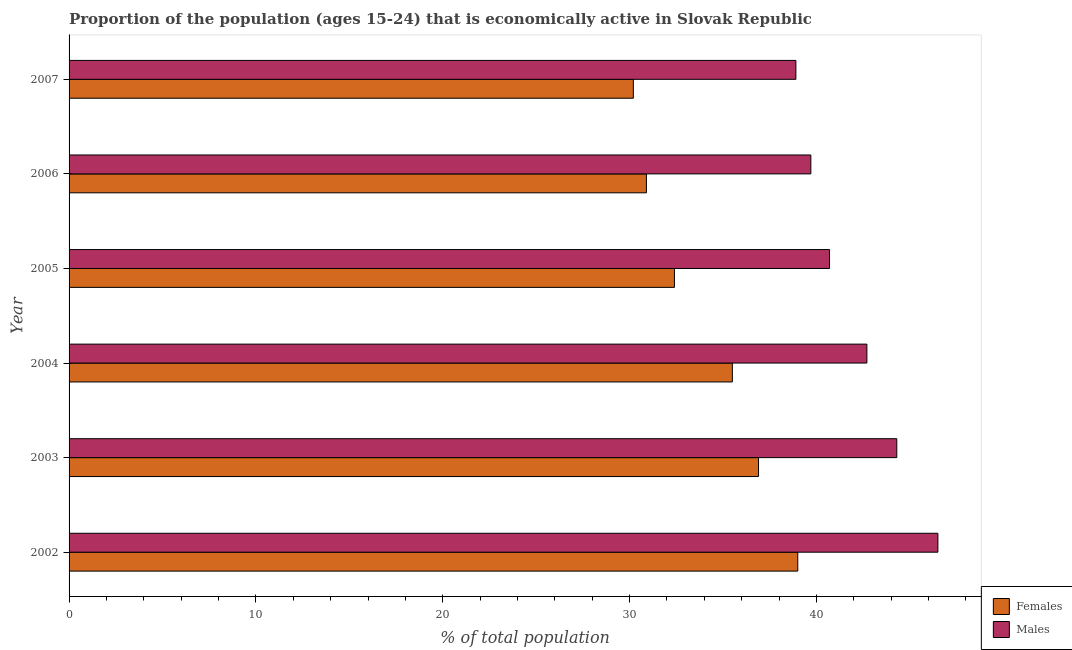How many different coloured bars are there?
Your response must be concise. 2. Are the number of bars per tick equal to the number of legend labels?
Offer a very short reply. Yes. Are the number of bars on each tick of the Y-axis equal?
Offer a very short reply. Yes. How many bars are there on the 3rd tick from the top?
Your response must be concise. 2. How many bars are there on the 1st tick from the bottom?
Offer a very short reply. 2. What is the percentage of economically active male population in 2004?
Make the answer very short. 42.7. Across all years, what is the maximum percentage of economically active female population?
Make the answer very short. 39. Across all years, what is the minimum percentage of economically active male population?
Your answer should be very brief. 38.9. In which year was the percentage of economically active female population minimum?
Your answer should be compact. 2007. What is the total percentage of economically active female population in the graph?
Provide a succinct answer. 204.9. What is the difference between the percentage of economically active male population in 2003 and that in 2006?
Your answer should be very brief. 4.6. What is the difference between the percentage of economically active male population in 2006 and the percentage of economically active female population in 2007?
Offer a terse response. 9.5. What is the average percentage of economically active female population per year?
Your answer should be compact. 34.15. In the year 2007, what is the difference between the percentage of economically active female population and percentage of economically active male population?
Your response must be concise. -8.7. What is the ratio of the percentage of economically active female population in 2003 to that in 2007?
Offer a very short reply. 1.22. Is the percentage of economically active male population in 2002 less than that in 2006?
Provide a succinct answer. No. What is the difference between the highest and the second highest percentage of economically active male population?
Your answer should be compact. 2.2. What is the difference between the highest and the lowest percentage of economically active female population?
Your answer should be very brief. 8.8. In how many years, is the percentage of economically active female population greater than the average percentage of economically active female population taken over all years?
Keep it short and to the point. 3. Is the sum of the percentage of economically active male population in 2002 and 2006 greater than the maximum percentage of economically active female population across all years?
Offer a terse response. Yes. What does the 2nd bar from the top in 2007 represents?
Your answer should be compact. Females. What does the 2nd bar from the bottom in 2007 represents?
Ensure brevity in your answer.  Males. How many bars are there?
Keep it short and to the point. 12. Are all the bars in the graph horizontal?
Provide a short and direct response. Yes. How many years are there in the graph?
Keep it short and to the point. 6. What is the difference between two consecutive major ticks on the X-axis?
Provide a succinct answer. 10. Are the values on the major ticks of X-axis written in scientific E-notation?
Your answer should be very brief. No. How many legend labels are there?
Offer a very short reply. 2. What is the title of the graph?
Your response must be concise. Proportion of the population (ages 15-24) that is economically active in Slovak Republic. Does "Underweight" appear as one of the legend labels in the graph?
Provide a short and direct response. No. What is the label or title of the X-axis?
Ensure brevity in your answer.  % of total population. What is the label or title of the Y-axis?
Make the answer very short. Year. What is the % of total population of Females in 2002?
Provide a short and direct response. 39. What is the % of total population of Males in 2002?
Give a very brief answer. 46.5. What is the % of total population of Females in 2003?
Offer a very short reply. 36.9. What is the % of total population in Males in 2003?
Ensure brevity in your answer.  44.3. What is the % of total population of Females in 2004?
Ensure brevity in your answer.  35.5. What is the % of total population of Males in 2004?
Keep it short and to the point. 42.7. What is the % of total population in Females in 2005?
Your answer should be very brief. 32.4. What is the % of total population in Males in 2005?
Ensure brevity in your answer.  40.7. What is the % of total population in Females in 2006?
Keep it short and to the point. 30.9. What is the % of total population in Males in 2006?
Provide a short and direct response. 39.7. What is the % of total population of Females in 2007?
Keep it short and to the point. 30.2. What is the % of total population in Males in 2007?
Give a very brief answer. 38.9. Across all years, what is the maximum % of total population of Males?
Your response must be concise. 46.5. Across all years, what is the minimum % of total population of Females?
Keep it short and to the point. 30.2. Across all years, what is the minimum % of total population in Males?
Provide a succinct answer. 38.9. What is the total % of total population in Females in the graph?
Your answer should be very brief. 204.9. What is the total % of total population of Males in the graph?
Your response must be concise. 252.8. What is the difference between the % of total population in Males in 2002 and that in 2004?
Provide a succinct answer. 3.8. What is the difference between the % of total population of Males in 2002 and that in 2005?
Your answer should be very brief. 5.8. What is the difference between the % of total population in Females in 2002 and that in 2006?
Your answer should be very brief. 8.1. What is the difference between the % of total population of Males in 2002 and that in 2006?
Offer a very short reply. 6.8. What is the difference between the % of total population of Females in 2002 and that in 2007?
Give a very brief answer. 8.8. What is the difference between the % of total population of Males in 2003 and that in 2004?
Give a very brief answer. 1.6. What is the difference between the % of total population of Females in 2003 and that in 2005?
Offer a terse response. 4.5. What is the difference between the % of total population in Males in 2003 and that in 2005?
Your response must be concise. 3.6. What is the difference between the % of total population in Females in 2003 and that in 2006?
Your answer should be compact. 6. What is the difference between the % of total population of Males in 2003 and that in 2006?
Provide a short and direct response. 4.6. What is the difference between the % of total population of Females in 2003 and that in 2007?
Ensure brevity in your answer.  6.7. What is the difference between the % of total population of Males in 2003 and that in 2007?
Offer a terse response. 5.4. What is the difference between the % of total population of Females in 2004 and that in 2005?
Make the answer very short. 3.1. What is the difference between the % of total population of Males in 2004 and that in 2006?
Offer a terse response. 3. What is the difference between the % of total population of Females in 2004 and that in 2007?
Give a very brief answer. 5.3. What is the difference between the % of total population of Males in 2005 and that in 2006?
Offer a terse response. 1. What is the difference between the % of total population in Males in 2005 and that in 2007?
Offer a terse response. 1.8. What is the difference between the % of total population in Females in 2006 and that in 2007?
Your answer should be compact. 0.7. What is the difference between the % of total population in Males in 2006 and that in 2007?
Offer a terse response. 0.8. What is the difference between the % of total population of Females in 2002 and the % of total population of Males in 2004?
Offer a very short reply. -3.7. What is the difference between the % of total population in Females in 2002 and the % of total population in Males in 2005?
Your response must be concise. -1.7. What is the difference between the % of total population of Females in 2002 and the % of total population of Males in 2006?
Offer a very short reply. -0.7. What is the difference between the % of total population in Females in 2003 and the % of total population in Males in 2005?
Keep it short and to the point. -3.8. What is the difference between the % of total population in Females in 2004 and the % of total population in Males in 2005?
Ensure brevity in your answer.  -5.2. What is the difference between the % of total population of Females in 2004 and the % of total population of Males in 2006?
Your response must be concise. -4.2. What is the difference between the % of total population of Females in 2005 and the % of total population of Males in 2006?
Offer a terse response. -7.3. What is the difference between the % of total population of Females in 2005 and the % of total population of Males in 2007?
Make the answer very short. -6.5. What is the difference between the % of total population in Females in 2006 and the % of total population in Males in 2007?
Offer a very short reply. -8. What is the average % of total population in Females per year?
Give a very brief answer. 34.15. What is the average % of total population in Males per year?
Offer a terse response. 42.13. In the year 2002, what is the difference between the % of total population of Females and % of total population of Males?
Ensure brevity in your answer.  -7.5. In the year 2003, what is the difference between the % of total population in Females and % of total population in Males?
Offer a very short reply. -7.4. In the year 2005, what is the difference between the % of total population of Females and % of total population of Males?
Provide a succinct answer. -8.3. In the year 2006, what is the difference between the % of total population of Females and % of total population of Males?
Make the answer very short. -8.8. In the year 2007, what is the difference between the % of total population in Females and % of total population in Males?
Your answer should be very brief. -8.7. What is the ratio of the % of total population in Females in 2002 to that in 2003?
Offer a terse response. 1.06. What is the ratio of the % of total population of Males in 2002 to that in 2003?
Offer a very short reply. 1.05. What is the ratio of the % of total population in Females in 2002 to that in 2004?
Your answer should be compact. 1.1. What is the ratio of the % of total population in Males in 2002 to that in 2004?
Offer a terse response. 1.09. What is the ratio of the % of total population in Females in 2002 to that in 2005?
Offer a terse response. 1.2. What is the ratio of the % of total population in Males in 2002 to that in 2005?
Offer a terse response. 1.14. What is the ratio of the % of total population in Females in 2002 to that in 2006?
Ensure brevity in your answer.  1.26. What is the ratio of the % of total population of Males in 2002 to that in 2006?
Make the answer very short. 1.17. What is the ratio of the % of total population in Females in 2002 to that in 2007?
Offer a terse response. 1.29. What is the ratio of the % of total population of Males in 2002 to that in 2007?
Ensure brevity in your answer.  1.2. What is the ratio of the % of total population of Females in 2003 to that in 2004?
Provide a short and direct response. 1.04. What is the ratio of the % of total population of Males in 2003 to that in 2004?
Make the answer very short. 1.04. What is the ratio of the % of total population in Females in 2003 to that in 2005?
Make the answer very short. 1.14. What is the ratio of the % of total population in Males in 2003 to that in 2005?
Provide a short and direct response. 1.09. What is the ratio of the % of total population of Females in 2003 to that in 2006?
Your answer should be very brief. 1.19. What is the ratio of the % of total population in Males in 2003 to that in 2006?
Offer a terse response. 1.12. What is the ratio of the % of total population of Females in 2003 to that in 2007?
Provide a succinct answer. 1.22. What is the ratio of the % of total population in Males in 2003 to that in 2007?
Your answer should be compact. 1.14. What is the ratio of the % of total population of Females in 2004 to that in 2005?
Keep it short and to the point. 1.1. What is the ratio of the % of total population in Males in 2004 to that in 2005?
Offer a very short reply. 1.05. What is the ratio of the % of total population in Females in 2004 to that in 2006?
Provide a succinct answer. 1.15. What is the ratio of the % of total population of Males in 2004 to that in 2006?
Offer a very short reply. 1.08. What is the ratio of the % of total population of Females in 2004 to that in 2007?
Provide a succinct answer. 1.18. What is the ratio of the % of total population in Males in 2004 to that in 2007?
Keep it short and to the point. 1.1. What is the ratio of the % of total population of Females in 2005 to that in 2006?
Offer a terse response. 1.05. What is the ratio of the % of total population of Males in 2005 to that in 2006?
Your answer should be compact. 1.03. What is the ratio of the % of total population of Females in 2005 to that in 2007?
Offer a terse response. 1.07. What is the ratio of the % of total population of Males in 2005 to that in 2007?
Ensure brevity in your answer.  1.05. What is the ratio of the % of total population of Females in 2006 to that in 2007?
Your response must be concise. 1.02. What is the ratio of the % of total population in Males in 2006 to that in 2007?
Your answer should be very brief. 1.02. What is the difference between the highest and the second highest % of total population in Females?
Offer a terse response. 2.1. What is the difference between the highest and the second highest % of total population of Males?
Give a very brief answer. 2.2. What is the difference between the highest and the lowest % of total population in Females?
Make the answer very short. 8.8. What is the difference between the highest and the lowest % of total population of Males?
Your response must be concise. 7.6. 